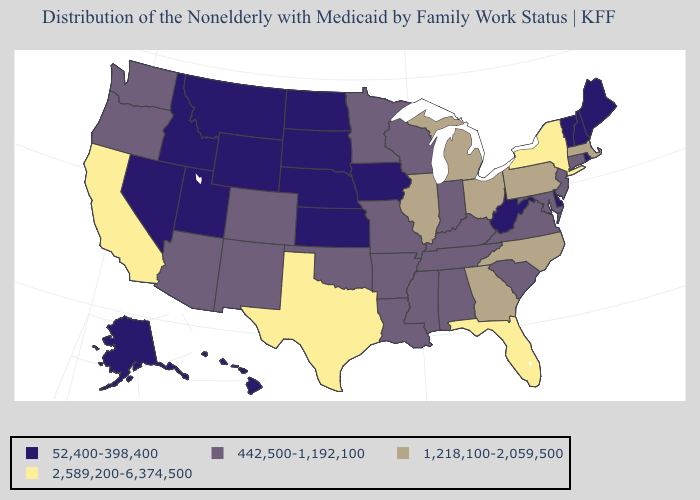Name the states that have a value in the range 52,400-398,400?
Be succinct. Alaska, Delaware, Hawaii, Idaho, Iowa, Kansas, Maine, Montana, Nebraska, Nevada, New Hampshire, North Dakota, Rhode Island, South Dakota, Utah, Vermont, West Virginia, Wyoming. Does Louisiana have the highest value in the USA?
Quick response, please. No. What is the value of Oregon?
Give a very brief answer. 442,500-1,192,100. Name the states that have a value in the range 1,218,100-2,059,500?
Quick response, please. Georgia, Illinois, Massachusetts, Michigan, North Carolina, Ohio, Pennsylvania. What is the highest value in the MidWest ?
Concise answer only. 1,218,100-2,059,500. What is the highest value in the West ?
Quick response, please. 2,589,200-6,374,500. What is the highest value in the Northeast ?
Answer briefly. 2,589,200-6,374,500. Which states have the highest value in the USA?
Give a very brief answer. California, Florida, New York, Texas. Name the states that have a value in the range 52,400-398,400?
Give a very brief answer. Alaska, Delaware, Hawaii, Idaho, Iowa, Kansas, Maine, Montana, Nebraska, Nevada, New Hampshire, North Dakota, Rhode Island, South Dakota, Utah, Vermont, West Virginia, Wyoming. Name the states that have a value in the range 2,589,200-6,374,500?
Write a very short answer. California, Florida, New York, Texas. Does New York have the highest value in the USA?
Be succinct. Yes. Which states have the lowest value in the USA?
Quick response, please. Alaska, Delaware, Hawaii, Idaho, Iowa, Kansas, Maine, Montana, Nebraska, Nevada, New Hampshire, North Dakota, Rhode Island, South Dakota, Utah, Vermont, West Virginia, Wyoming. Does New York have the highest value in the Northeast?
Write a very short answer. Yes. Does Georgia have the highest value in the USA?
Write a very short answer. No. Does North Carolina have the same value as Pennsylvania?
Quick response, please. Yes. 